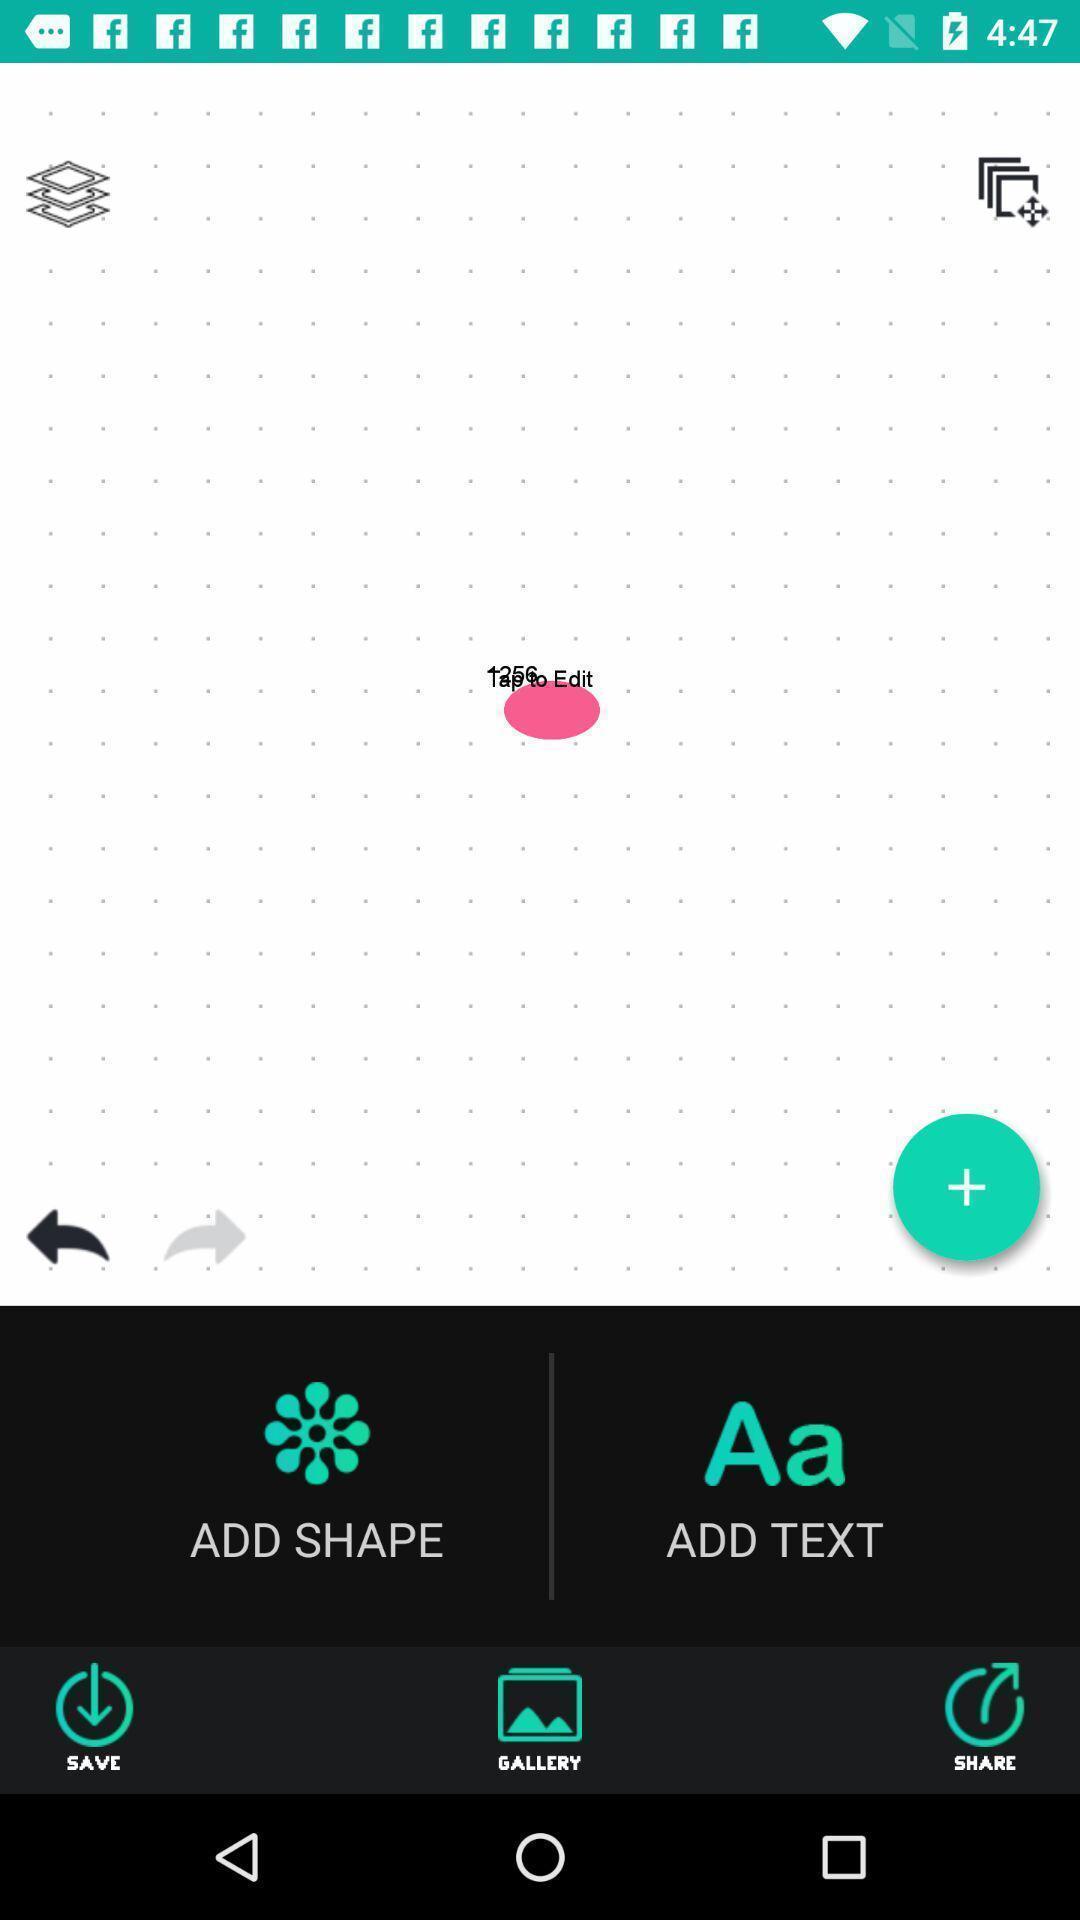Describe this image in words. Screen shows an edit option. 